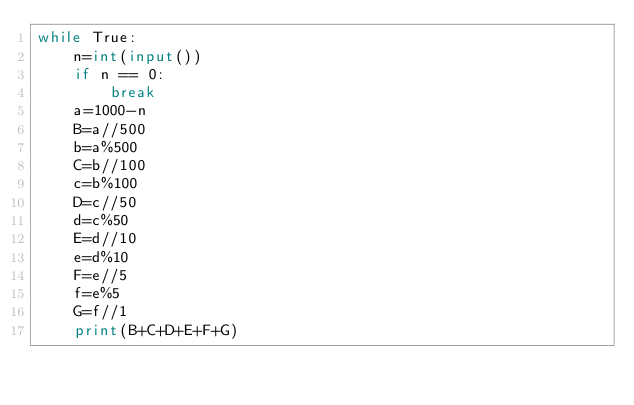Convert code to text. <code><loc_0><loc_0><loc_500><loc_500><_Python_>while True:
    n=int(input())
    if n == 0:
        break
    a=1000-n
    B=a//500
    b=a%500
    C=b//100
    c=b%100
    D=c//50
    d=c%50
    E=d//10
    e=d%10
    F=e//5
    f=e%5
    G=f//1
    print(B+C+D+E+F+G)
    
</code> 